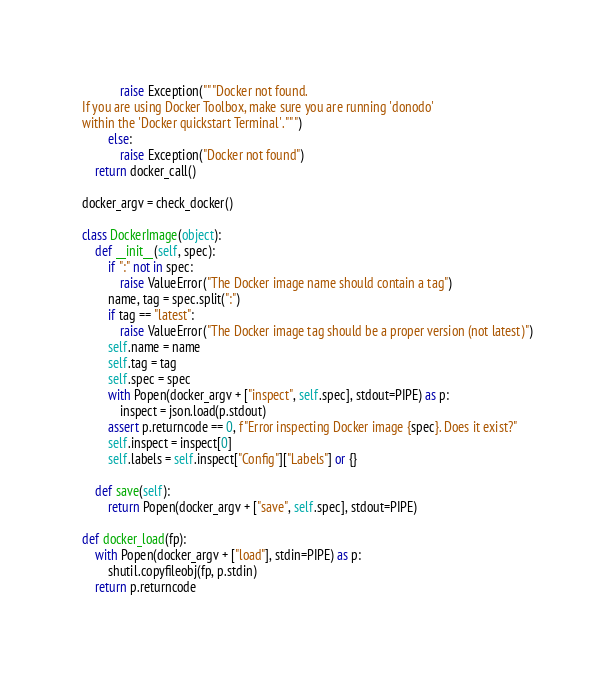<code> <loc_0><loc_0><loc_500><loc_500><_Python_>            raise Exception("""Docker not found.
If you are using Docker Toolbox, make sure you are running 'donodo'
within the 'Docker quickstart Terminal'.""")
        else:
            raise Exception("Docker not found")
    return docker_call()

docker_argv = check_docker()

class DockerImage(object):
    def __init__(self, spec):
        if ":" not in spec:
            raise ValueError("The Docker image name should contain a tag")
        name, tag = spec.split(":")
        if tag == "latest":
            raise ValueError("The Docker image tag should be a proper version (not latest)")
        self.name = name
        self.tag = tag
        self.spec = spec
        with Popen(docker_argv + ["inspect", self.spec], stdout=PIPE) as p:
            inspect = json.load(p.stdout)
        assert p.returncode == 0, f"Error inspecting Docker image {spec}. Does it exist?"
        self.inspect = inspect[0]
        self.labels = self.inspect["Config"]["Labels"] or {}

    def save(self):
        return Popen(docker_argv + ["save", self.spec], stdout=PIPE)

def docker_load(fp):
    with Popen(docker_argv + ["load"], stdin=PIPE) as p:
        shutil.copyfileobj(fp, p.stdin)
    return p.returncode
</code> 